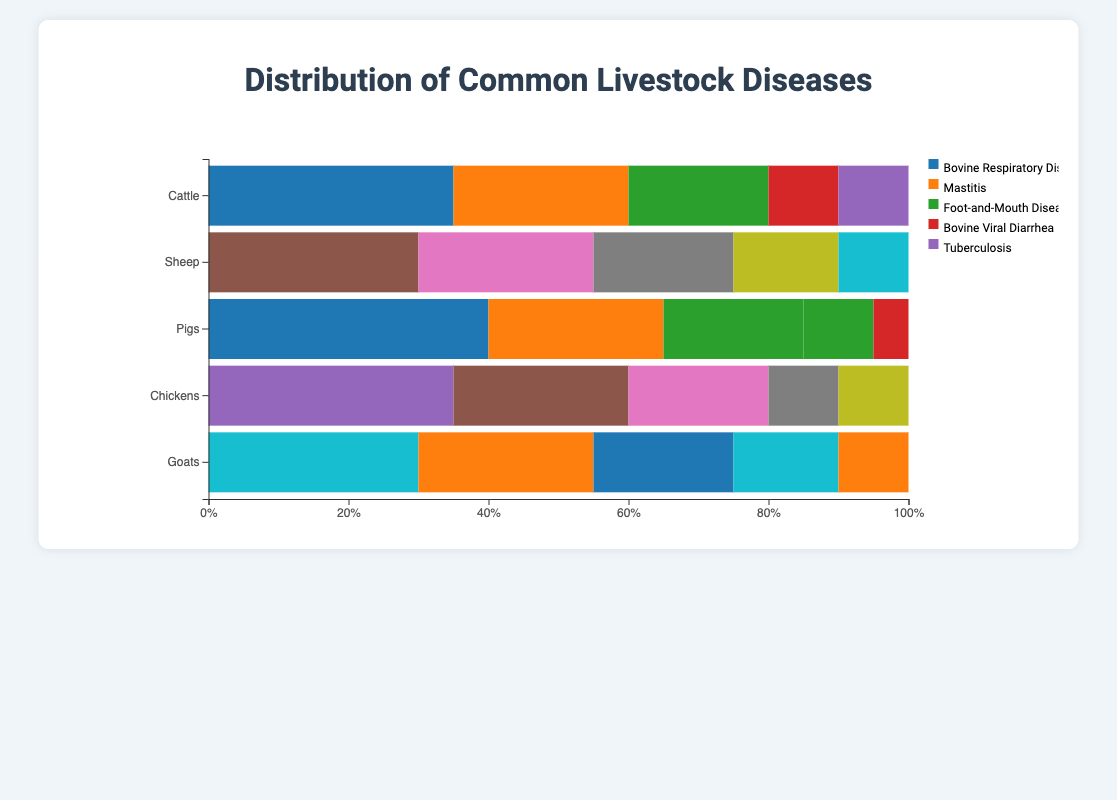What are the three most common diseases affecting Cattle? To identify the most common diseases in Cattle, look for the three largest segments in the horizontal bar for Cattle. These segments are Bovine Respiratory Disease, Mastitis, and Foot-and-Mouth Disease.
Answer: Bovine Respiratory Disease, Mastitis, Foot-and-Mouth Disease Which species has the highest percentage of Mastitis cases? To determine which species has the highest percentage of Mastitis, compare the Mastitis segments across all species. The longest segment for Mastitis appears in Goats.
Answer: Goats What is the combined percentage of Foot-and-Mouth Disease in Cattle and Pigs? To find the combined percentage, add the percentage of Foot-and-Mouth Disease in Cattle (20%) and Pigs (10%). So, 20% + 10% = 30%.
Answer: 30% Which disease is equally prevalent in both Cattle and Goats? Scan the diseases listed under both Cattle and Goats and compare percentages. Mastitis is the disease with equal prevalence in Cattle and Goats (both at 25%).
Answer: Mastitis How does the prevalence of Bovine Respiratory Disease in Cattle compare to that of Newcastle Disease in Chickens? To compare these diseases, look at the lengths of the respective segments for each species. Both Bovine Respiratory Disease in Cattle and Newcastle Disease in Chickens have the same percentage (35%).
Answer: Equal Which species has the largest segment for a single disease, and what is that disease? Look for the largest individual segment across all species. The largest single segment belongs to Pigs for Porcine Reproductive and Respiratory Syndrome (40%).
Answer: Pigs, Porcine Reproductive and Respiratory Syndrome What is the difference in percentage between Foot Rot in Sheep and Mastitis in Goats? Calculate the difference by subtracting the percentage of Mastitis in Goats (25%) from the percentage of Foot Rot in Sheep (30%). So, 30% - 25% = 5%.
Answer: 5% What is the proportion of Newcastle Disease in Chickens relative to the total disease distribution of Chickens? The total percentage for all diseases in Chickens is 100%. Newcastle Disease occupies 35%, so the proportion is 35/100, which is 0.35 or 35%.
Answer: 35% What is the average percentage of the top three diseases in Sheep? The top three diseases by percentage in Sheep are Foot Rot (30%), Bluetongue (25%), and Scrapie (20%). The average is calculated as (30 + 25 + 20) / 3 = 75 / 3 = 25%.
Answer: 25% Which species has the smallest percentage attributed to Salmonellosis, and what is that percentage? Of all the species, only Pigs have Salmonellosis listed, and its percentage is 5%. This is the smallest percentage for Salmonellosis across the figure.
Answer: Pigs, 5% 